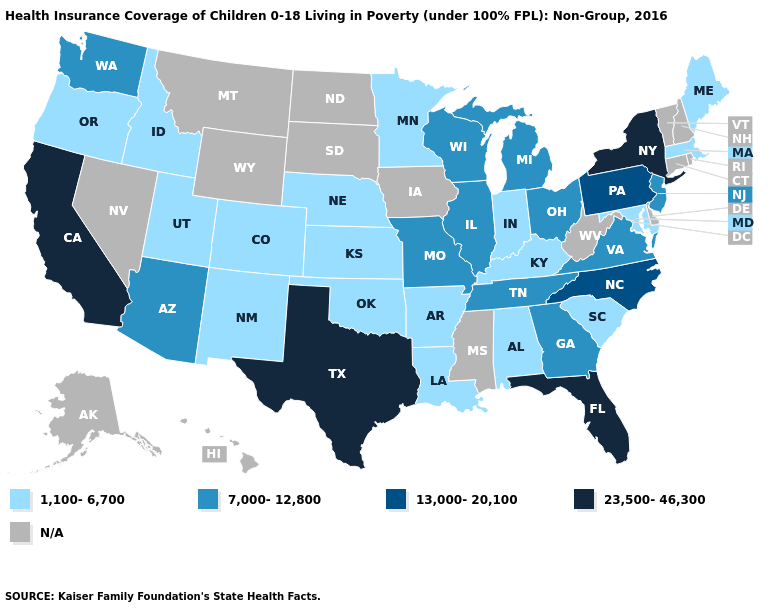What is the value of Maryland?
Be succinct. 1,100-6,700. What is the value of Oregon?
Answer briefly. 1,100-6,700. Name the states that have a value in the range 1,100-6,700?
Keep it brief. Alabama, Arkansas, Colorado, Idaho, Indiana, Kansas, Kentucky, Louisiana, Maine, Maryland, Massachusetts, Minnesota, Nebraska, New Mexico, Oklahoma, Oregon, South Carolina, Utah. Does Pennsylvania have the highest value in the Northeast?
Quick response, please. No. Does New York have the highest value in the USA?
Answer briefly. Yes. How many symbols are there in the legend?
Quick response, please. 5. Which states have the lowest value in the USA?
Write a very short answer. Alabama, Arkansas, Colorado, Idaho, Indiana, Kansas, Kentucky, Louisiana, Maine, Maryland, Massachusetts, Minnesota, Nebraska, New Mexico, Oklahoma, Oregon, South Carolina, Utah. Does Nebraska have the lowest value in the MidWest?
Answer briefly. Yes. What is the value of Nebraska?
Answer briefly. 1,100-6,700. What is the lowest value in the USA?
Keep it brief. 1,100-6,700. What is the value of Louisiana?
Be succinct. 1,100-6,700. Name the states that have a value in the range 13,000-20,100?
Be succinct. North Carolina, Pennsylvania. Is the legend a continuous bar?
Give a very brief answer. No. What is the highest value in the South ?
Answer briefly. 23,500-46,300. 